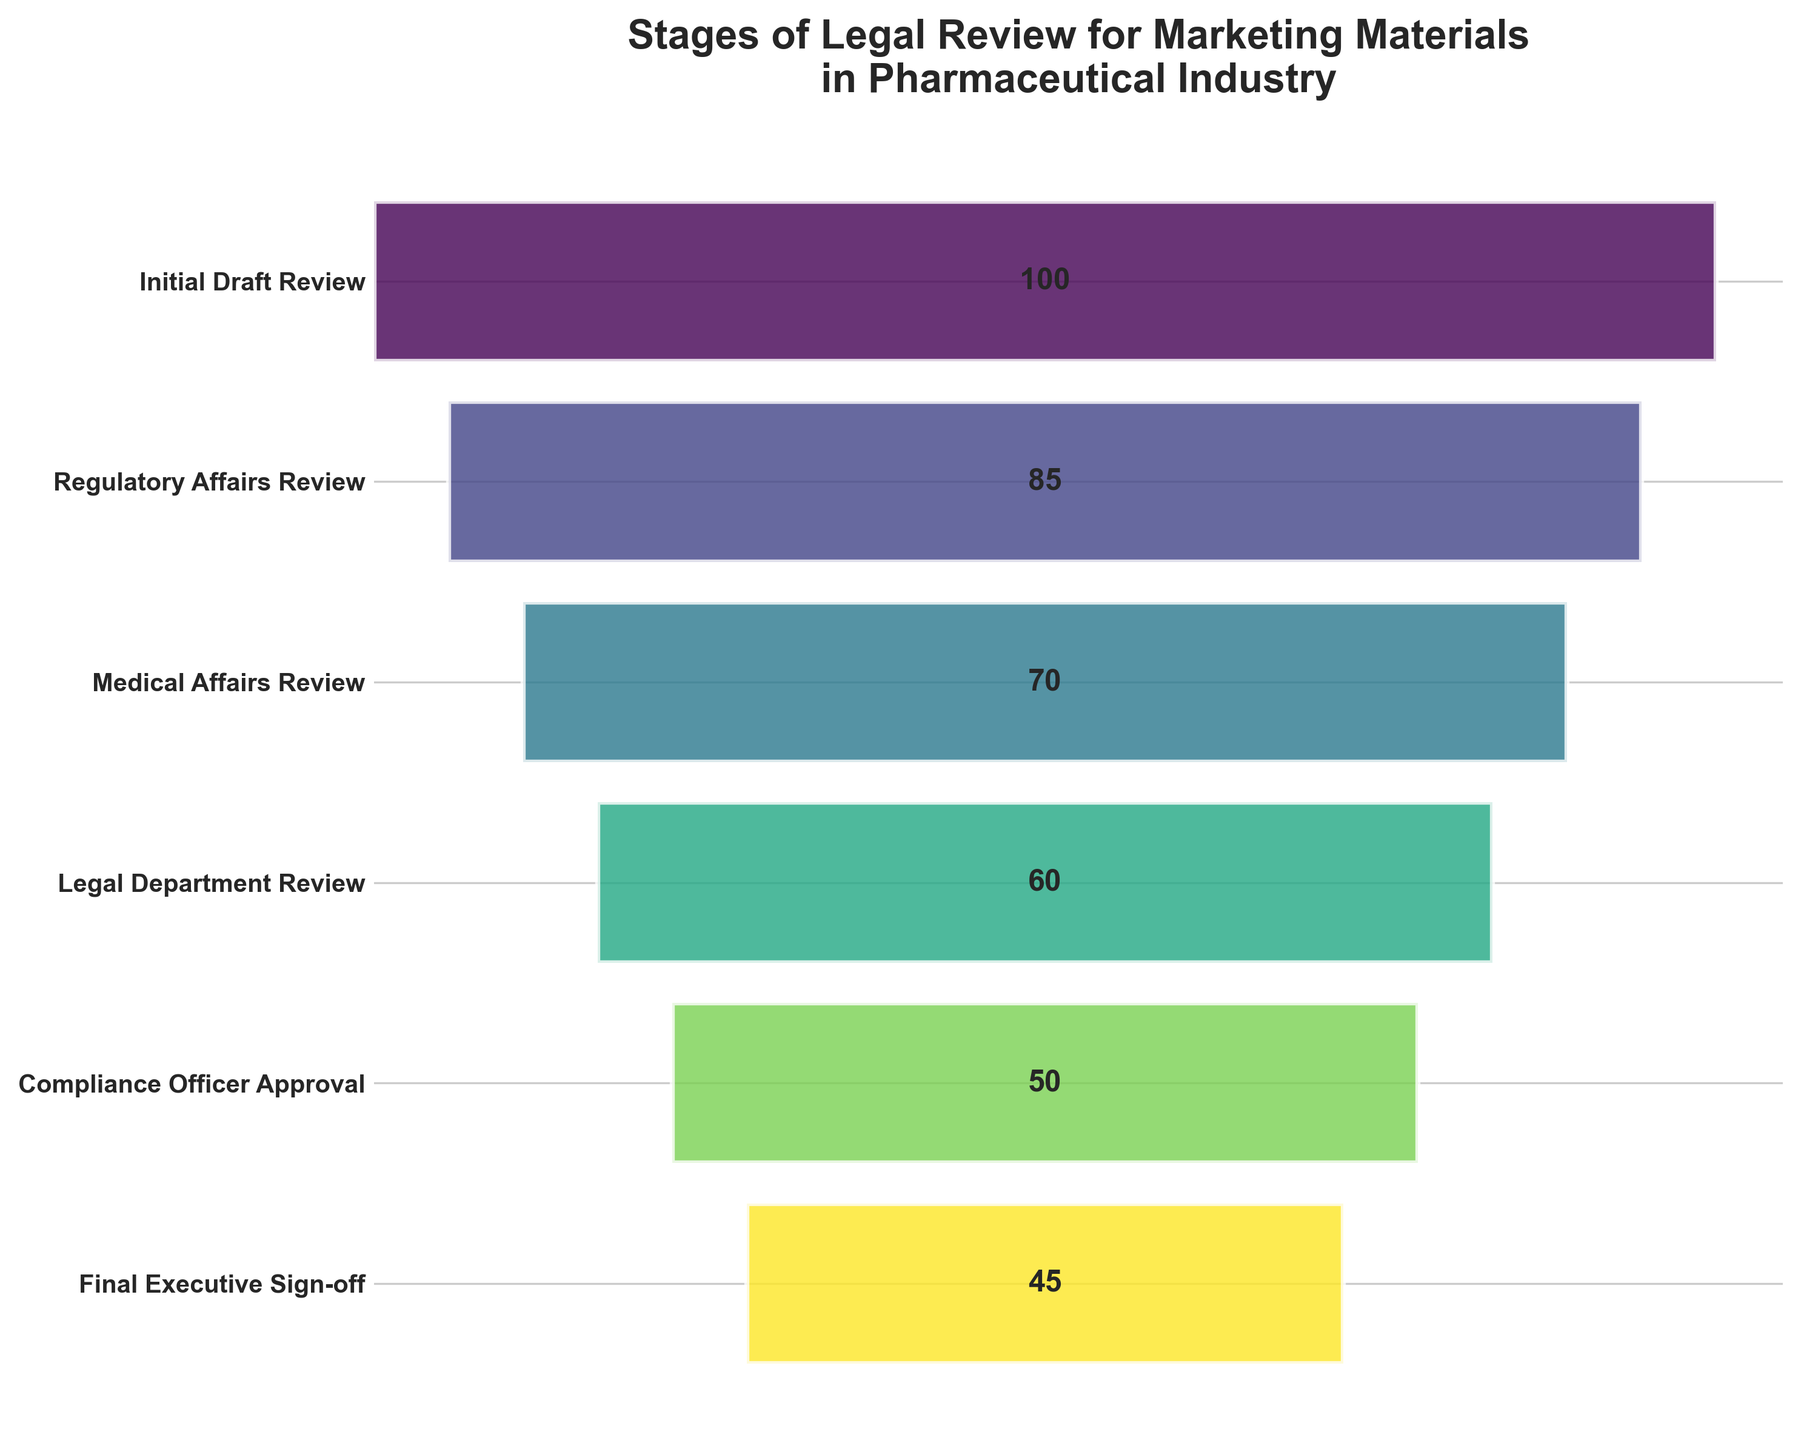What's the title of the funnel chart? The title of the chart is usually displayed at the top. In this case, the title is "Stages of Legal Review for Marketing Materials in Pharmaceutical Industry" as it clearly describes the context and topic of the data visualized.
Answer: Stages of Legal Review for Marketing Materials in Pharmaceutical Industry How many stages are represented in the funnel chart? To determine the number of stages, count the distinct horizontal segments representing each stage. In this case, there are six stages mentioned.
Answer: Six What stage has the highest number of materials? Look at the topmost stage in the funnel chart, which represents the initial point in the process. This stage shows the highest value on the horizontal bar.
Answer: Initial Draft Review Which stage shows the largest reduction in the number of materials compared to the previous stage? Analyze the difference in numbers between consecutive stages and identify which difference is the greatest. The largest reduction can be observed between "Medical Affairs Review" (70) and "Legal Department Review" (60), indicating a reduction of 10 materials.
Answer: Medical Affairs Review to Legal Department Review What is the total number of materials that reach the final executive sign-off stage? The number of materials at the final stage can be directly read from the funnel chart, which shows the number adjacent to "Final Executive Sign-off."
Answer: 45 What is the average number of materials reviewed across all stages? Calculate the sum of the number of materials across all stages and divide by the number of stages. Sum is 100 + 85 + 70 + 60 + 50 + 45 = 410. There are six stages, so the average is 410 / 6 ≈ 68.33.
Answer: 68.33 How many materials are reviewed after the Regulatory Affairs Review? To find this, add the number of materials from the Regulatory Affairs Review stage onwards: 85 at Regulatory Affairs Review, 70 at Medical Affairs Review, 60 at Legal Department Review, 50 at Compliance Officer Approval, and 45 at Final Executive Sign-off. This is 70 + 60 + 50 + 45 = 225.
Answer: 225 Which stage has the smallest number of materials? Look at the numbers for each segment in the funnel and identify the smallest value. The smallest number of materials is at the "Final Executive Sign-off" stage.
Answer: Final Executive Sign-off Between which stages does the number of materials decrease the least? Determine the difference in the number of materials between consecutive stages and identify the smallest difference. The smallest decrease is from "Compliance Officer Approval" (50) to "Final Executive Sign-off" (45), which is a reduction of 5 materials.
Answer: Compliance Officer Approval to Final Executive Sign-off 